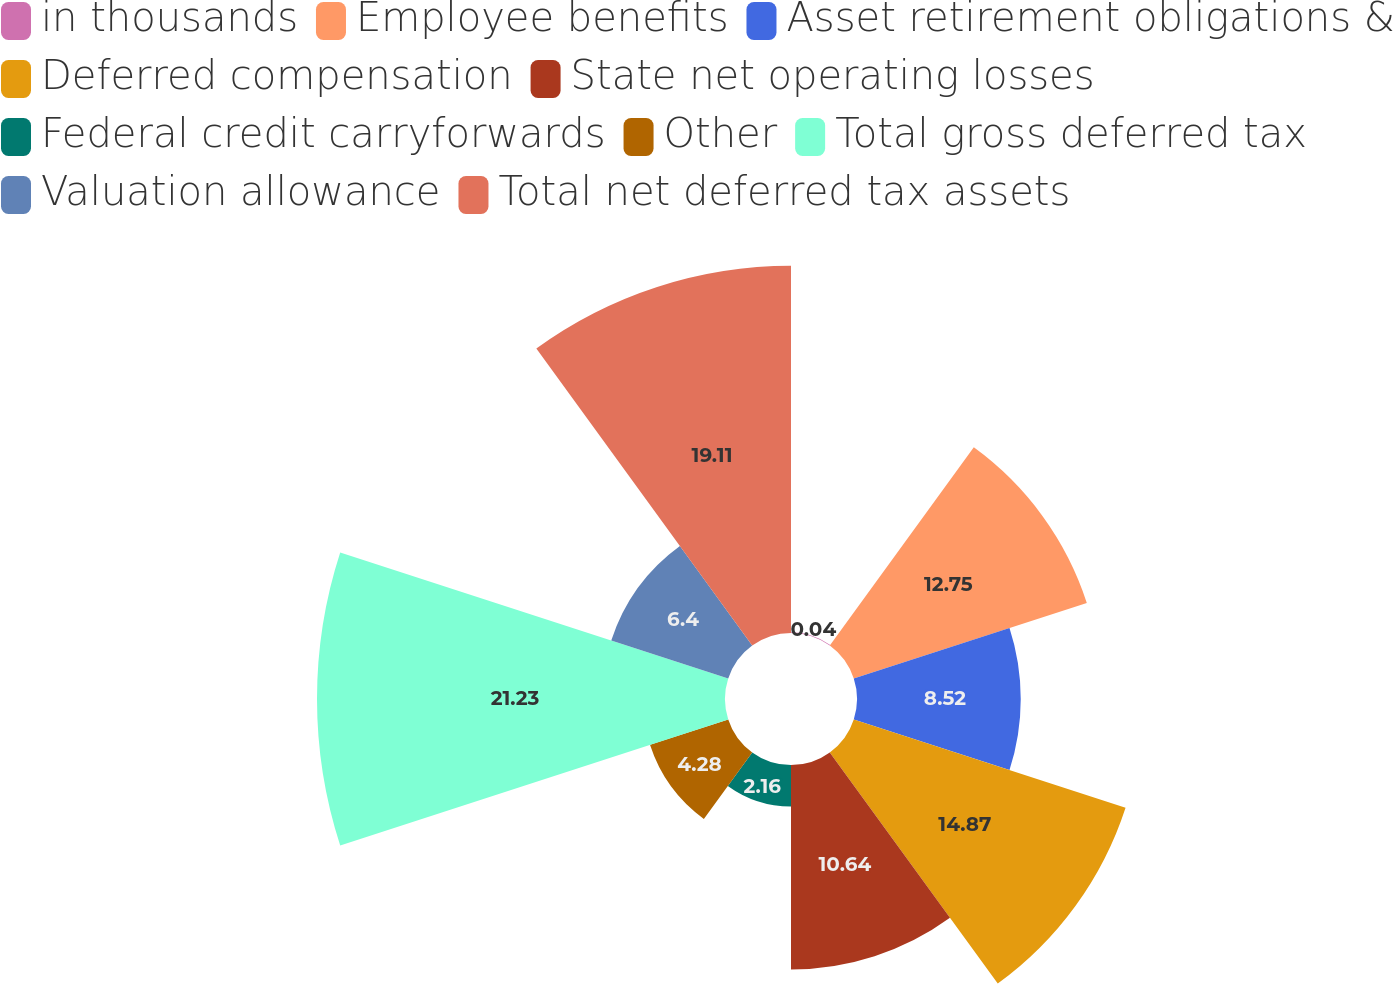<chart> <loc_0><loc_0><loc_500><loc_500><pie_chart><fcel>in thousands<fcel>Employee benefits<fcel>Asset retirement obligations &<fcel>Deferred compensation<fcel>State net operating losses<fcel>Federal credit carryforwards<fcel>Other<fcel>Total gross deferred tax<fcel>Valuation allowance<fcel>Total net deferred tax assets<nl><fcel>0.04%<fcel>12.75%<fcel>8.52%<fcel>14.87%<fcel>10.64%<fcel>2.16%<fcel>4.28%<fcel>21.23%<fcel>6.4%<fcel>19.11%<nl></chart> 